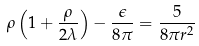Convert formula to latex. <formula><loc_0><loc_0><loc_500><loc_500>\rho \left ( 1 + \frac { \rho } { 2 \lambda } \right ) - \frac { \epsilon } { 8 \pi } = \frac { 5 } { 8 \pi r ^ { 2 } }</formula> 